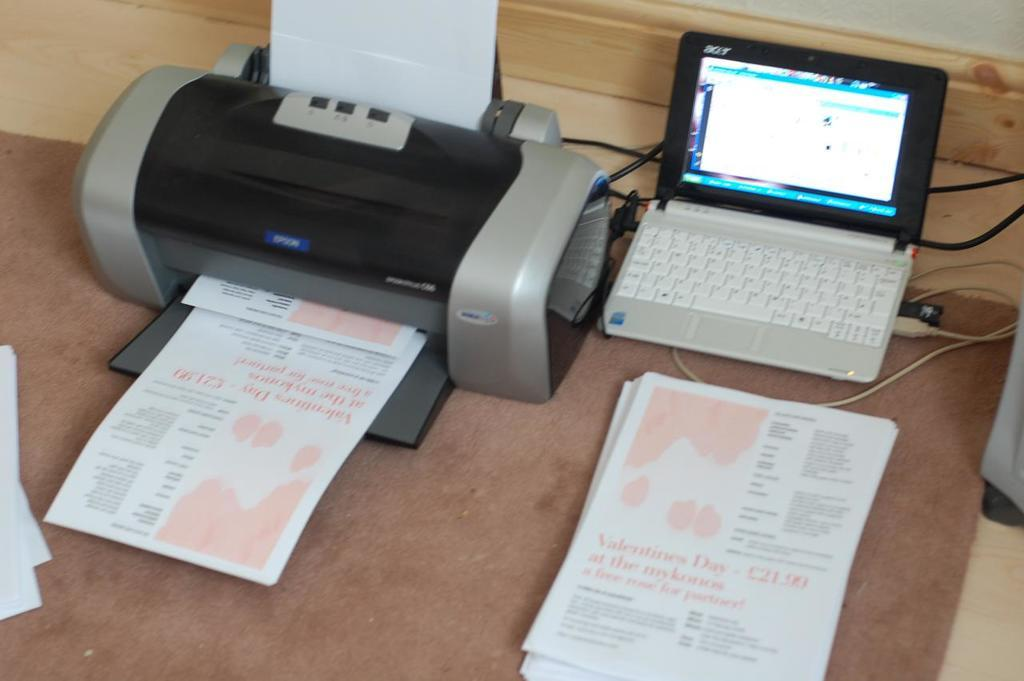What electronic device is located on the right side of the image? There is a laptop on the right side of the image. What device is on the left side of the image? There is a scanning machine on the left side of the image. What type of beast can be seen driving a vehicle in the image? There is no beast or vehicle present in the image. Is there a sweater visible on the laptop in the image? There is no sweater present in the image; it is a laptop and a scanning machine. 